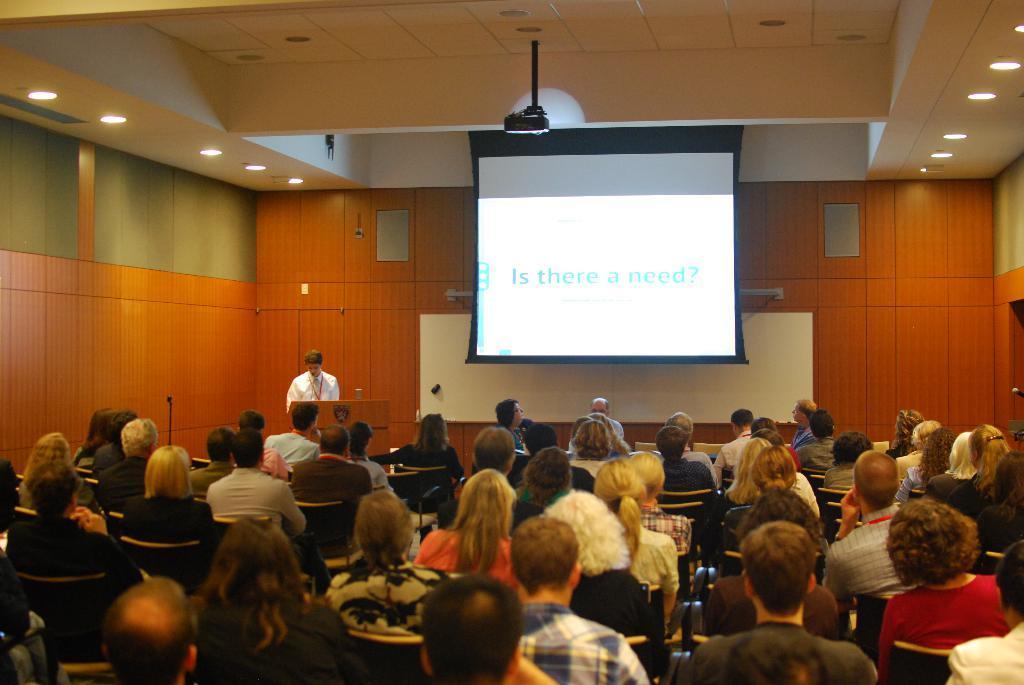In one or two sentences, can you explain what this image depicts? In this image I can see the group of people sitting. In the background I can see the person standing and I can also see the projection screen, few lights and the wall is in brown color. 